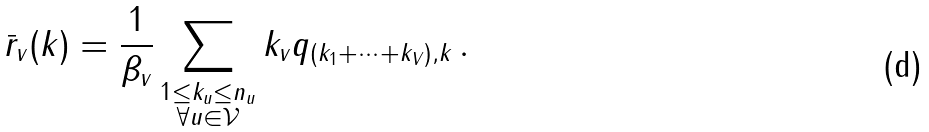Convert formula to latex. <formula><loc_0><loc_0><loc_500><loc_500>\bar { r } _ { v } ( k ) = \frac { 1 } { \beta _ { v } } \sum _ { \substack { 1 \leq k _ { u } \leq n _ { u } \\ \forall u \in \mathcal { V } } } k _ { v } q _ { ( k _ { 1 } + \cdots + k _ { V } ) , k } \, .</formula> 